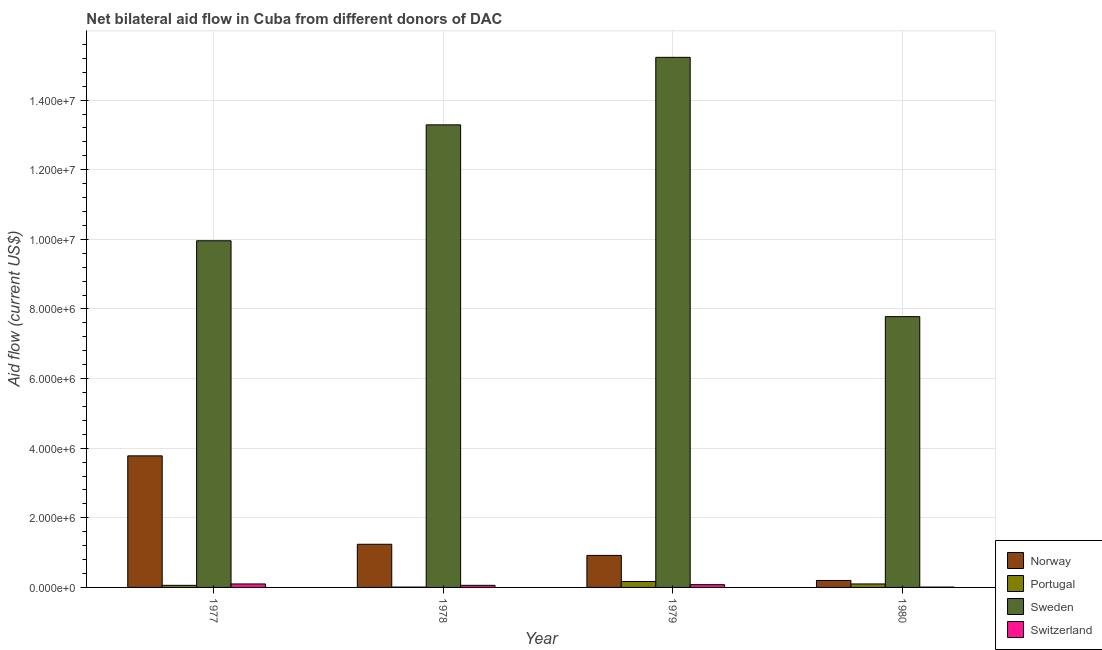How many different coloured bars are there?
Your answer should be very brief. 4. Are the number of bars per tick equal to the number of legend labels?
Your answer should be compact. Yes. Are the number of bars on each tick of the X-axis equal?
Provide a succinct answer. Yes. How many bars are there on the 2nd tick from the left?
Your response must be concise. 4. What is the label of the 3rd group of bars from the left?
Provide a short and direct response. 1979. In how many cases, is the number of bars for a given year not equal to the number of legend labels?
Ensure brevity in your answer.  0. What is the amount of aid given by portugal in 1977?
Make the answer very short. 6.00e+04. Across all years, what is the maximum amount of aid given by portugal?
Keep it short and to the point. 1.70e+05. Across all years, what is the minimum amount of aid given by norway?
Make the answer very short. 2.00e+05. In which year was the amount of aid given by switzerland maximum?
Give a very brief answer. 1977. In which year was the amount of aid given by portugal minimum?
Ensure brevity in your answer.  1978. What is the total amount of aid given by portugal in the graph?
Provide a succinct answer. 3.40e+05. What is the difference between the amount of aid given by norway in 1979 and that in 1980?
Make the answer very short. 7.20e+05. What is the difference between the amount of aid given by sweden in 1979 and the amount of aid given by norway in 1978?
Keep it short and to the point. 1.94e+06. What is the average amount of aid given by sweden per year?
Your answer should be compact. 1.16e+07. In the year 1979, what is the difference between the amount of aid given by portugal and amount of aid given by switzerland?
Keep it short and to the point. 0. In how many years, is the amount of aid given by sweden greater than 14400000 US$?
Your answer should be very brief. 1. Is the amount of aid given by switzerland in 1977 less than that in 1980?
Ensure brevity in your answer.  No. What is the difference between the highest and the second highest amount of aid given by sweden?
Provide a succinct answer. 1.94e+06. What is the difference between the highest and the lowest amount of aid given by portugal?
Make the answer very short. 1.60e+05. In how many years, is the amount of aid given by norway greater than the average amount of aid given by norway taken over all years?
Your response must be concise. 1. Is the sum of the amount of aid given by norway in 1977 and 1979 greater than the maximum amount of aid given by sweden across all years?
Provide a short and direct response. Yes. Is it the case that in every year, the sum of the amount of aid given by sweden and amount of aid given by switzerland is greater than the sum of amount of aid given by portugal and amount of aid given by norway?
Your answer should be compact. Yes. What does the 1st bar from the left in 1978 represents?
Keep it short and to the point. Norway. What does the 1st bar from the right in 1978 represents?
Your answer should be very brief. Switzerland. How many bars are there?
Offer a terse response. 16. Are all the bars in the graph horizontal?
Provide a succinct answer. No. How many years are there in the graph?
Give a very brief answer. 4. What is the difference between two consecutive major ticks on the Y-axis?
Offer a very short reply. 2.00e+06. Does the graph contain any zero values?
Keep it short and to the point. No. Does the graph contain grids?
Keep it short and to the point. Yes. How many legend labels are there?
Your answer should be very brief. 4. What is the title of the graph?
Offer a very short reply. Net bilateral aid flow in Cuba from different donors of DAC. What is the label or title of the X-axis?
Provide a succinct answer. Year. What is the Aid flow (current US$) in Norway in 1977?
Offer a terse response. 3.78e+06. What is the Aid flow (current US$) of Sweden in 1977?
Your response must be concise. 9.96e+06. What is the Aid flow (current US$) in Switzerland in 1977?
Your answer should be compact. 1.00e+05. What is the Aid flow (current US$) in Norway in 1978?
Ensure brevity in your answer.  1.24e+06. What is the Aid flow (current US$) of Portugal in 1978?
Offer a terse response. 10000. What is the Aid flow (current US$) of Sweden in 1978?
Your answer should be compact. 1.33e+07. What is the Aid flow (current US$) of Norway in 1979?
Keep it short and to the point. 9.20e+05. What is the Aid flow (current US$) of Sweden in 1979?
Provide a succinct answer. 1.52e+07. What is the Aid flow (current US$) in Portugal in 1980?
Keep it short and to the point. 1.00e+05. What is the Aid flow (current US$) in Sweden in 1980?
Make the answer very short. 7.78e+06. What is the Aid flow (current US$) in Switzerland in 1980?
Your response must be concise. 10000. Across all years, what is the maximum Aid flow (current US$) in Norway?
Provide a succinct answer. 3.78e+06. Across all years, what is the maximum Aid flow (current US$) in Portugal?
Your answer should be compact. 1.70e+05. Across all years, what is the maximum Aid flow (current US$) of Sweden?
Your answer should be very brief. 1.52e+07. Across all years, what is the minimum Aid flow (current US$) in Sweden?
Provide a short and direct response. 7.78e+06. What is the total Aid flow (current US$) in Norway in the graph?
Provide a succinct answer. 6.14e+06. What is the total Aid flow (current US$) in Portugal in the graph?
Your answer should be very brief. 3.40e+05. What is the total Aid flow (current US$) in Sweden in the graph?
Offer a very short reply. 4.63e+07. What is the difference between the Aid flow (current US$) in Norway in 1977 and that in 1978?
Make the answer very short. 2.54e+06. What is the difference between the Aid flow (current US$) of Portugal in 1977 and that in 1978?
Offer a terse response. 5.00e+04. What is the difference between the Aid flow (current US$) in Sweden in 1977 and that in 1978?
Your answer should be very brief. -3.33e+06. What is the difference between the Aid flow (current US$) in Switzerland in 1977 and that in 1978?
Provide a short and direct response. 4.00e+04. What is the difference between the Aid flow (current US$) of Norway in 1977 and that in 1979?
Your answer should be compact. 2.86e+06. What is the difference between the Aid flow (current US$) of Portugal in 1977 and that in 1979?
Your answer should be compact. -1.10e+05. What is the difference between the Aid flow (current US$) in Sweden in 1977 and that in 1979?
Keep it short and to the point. -5.27e+06. What is the difference between the Aid flow (current US$) in Norway in 1977 and that in 1980?
Make the answer very short. 3.58e+06. What is the difference between the Aid flow (current US$) in Portugal in 1977 and that in 1980?
Offer a very short reply. -4.00e+04. What is the difference between the Aid flow (current US$) of Sweden in 1977 and that in 1980?
Offer a terse response. 2.18e+06. What is the difference between the Aid flow (current US$) of Portugal in 1978 and that in 1979?
Provide a short and direct response. -1.60e+05. What is the difference between the Aid flow (current US$) of Sweden in 1978 and that in 1979?
Ensure brevity in your answer.  -1.94e+06. What is the difference between the Aid flow (current US$) of Switzerland in 1978 and that in 1979?
Offer a terse response. -2.00e+04. What is the difference between the Aid flow (current US$) in Norway in 1978 and that in 1980?
Provide a succinct answer. 1.04e+06. What is the difference between the Aid flow (current US$) in Portugal in 1978 and that in 1980?
Provide a short and direct response. -9.00e+04. What is the difference between the Aid flow (current US$) in Sweden in 1978 and that in 1980?
Keep it short and to the point. 5.51e+06. What is the difference between the Aid flow (current US$) of Switzerland in 1978 and that in 1980?
Your response must be concise. 5.00e+04. What is the difference between the Aid flow (current US$) of Norway in 1979 and that in 1980?
Your response must be concise. 7.20e+05. What is the difference between the Aid flow (current US$) of Sweden in 1979 and that in 1980?
Offer a very short reply. 7.45e+06. What is the difference between the Aid flow (current US$) in Norway in 1977 and the Aid flow (current US$) in Portugal in 1978?
Your answer should be very brief. 3.77e+06. What is the difference between the Aid flow (current US$) of Norway in 1977 and the Aid flow (current US$) of Sweden in 1978?
Your answer should be very brief. -9.51e+06. What is the difference between the Aid flow (current US$) in Norway in 1977 and the Aid flow (current US$) in Switzerland in 1978?
Make the answer very short. 3.72e+06. What is the difference between the Aid flow (current US$) in Portugal in 1977 and the Aid flow (current US$) in Sweden in 1978?
Keep it short and to the point. -1.32e+07. What is the difference between the Aid flow (current US$) of Sweden in 1977 and the Aid flow (current US$) of Switzerland in 1978?
Your answer should be compact. 9.90e+06. What is the difference between the Aid flow (current US$) in Norway in 1977 and the Aid flow (current US$) in Portugal in 1979?
Offer a very short reply. 3.61e+06. What is the difference between the Aid flow (current US$) of Norway in 1977 and the Aid flow (current US$) of Sweden in 1979?
Your answer should be very brief. -1.14e+07. What is the difference between the Aid flow (current US$) in Norway in 1977 and the Aid flow (current US$) in Switzerland in 1979?
Offer a terse response. 3.70e+06. What is the difference between the Aid flow (current US$) of Portugal in 1977 and the Aid flow (current US$) of Sweden in 1979?
Your answer should be compact. -1.52e+07. What is the difference between the Aid flow (current US$) in Portugal in 1977 and the Aid flow (current US$) in Switzerland in 1979?
Your answer should be compact. -2.00e+04. What is the difference between the Aid flow (current US$) in Sweden in 1977 and the Aid flow (current US$) in Switzerland in 1979?
Your answer should be compact. 9.88e+06. What is the difference between the Aid flow (current US$) in Norway in 1977 and the Aid flow (current US$) in Portugal in 1980?
Your answer should be compact. 3.68e+06. What is the difference between the Aid flow (current US$) of Norway in 1977 and the Aid flow (current US$) of Switzerland in 1980?
Your answer should be compact. 3.77e+06. What is the difference between the Aid flow (current US$) in Portugal in 1977 and the Aid flow (current US$) in Sweden in 1980?
Make the answer very short. -7.72e+06. What is the difference between the Aid flow (current US$) of Sweden in 1977 and the Aid flow (current US$) of Switzerland in 1980?
Provide a short and direct response. 9.95e+06. What is the difference between the Aid flow (current US$) of Norway in 1978 and the Aid flow (current US$) of Portugal in 1979?
Offer a terse response. 1.07e+06. What is the difference between the Aid flow (current US$) in Norway in 1978 and the Aid flow (current US$) in Sweden in 1979?
Provide a succinct answer. -1.40e+07. What is the difference between the Aid flow (current US$) in Norway in 1978 and the Aid flow (current US$) in Switzerland in 1979?
Make the answer very short. 1.16e+06. What is the difference between the Aid flow (current US$) of Portugal in 1978 and the Aid flow (current US$) of Sweden in 1979?
Offer a very short reply. -1.52e+07. What is the difference between the Aid flow (current US$) in Sweden in 1978 and the Aid flow (current US$) in Switzerland in 1979?
Your response must be concise. 1.32e+07. What is the difference between the Aid flow (current US$) of Norway in 1978 and the Aid flow (current US$) of Portugal in 1980?
Give a very brief answer. 1.14e+06. What is the difference between the Aid flow (current US$) in Norway in 1978 and the Aid flow (current US$) in Sweden in 1980?
Offer a terse response. -6.54e+06. What is the difference between the Aid flow (current US$) of Norway in 1978 and the Aid flow (current US$) of Switzerland in 1980?
Provide a short and direct response. 1.23e+06. What is the difference between the Aid flow (current US$) of Portugal in 1978 and the Aid flow (current US$) of Sweden in 1980?
Offer a terse response. -7.77e+06. What is the difference between the Aid flow (current US$) of Portugal in 1978 and the Aid flow (current US$) of Switzerland in 1980?
Provide a succinct answer. 0. What is the difference between the Aid flow (current US$) in Sweden in 1978 and the Aid flow (current US$) in Switzerland in 1980?
Your answer should be compact. 1.33e+07. What is the difference between the Aid flow (current US$) of Norway in 1979 and the Aid flow (current US$) of Portugal in 1980?
Give a very brief answer. 8.20e+05. What is the difference between the Aid flow (current US$) in Norway in 1979 and the Aid flow (current US$) in Sweden in 1980?
Provide a short and direct response. -6.86e+06. What is the difference between the Aid flow (current US$) in Norway in 1979 and the Aid flow (current US$) in Switzerland in 1980?
Give a very brief answer. 9.10e+05. What is the difference between the Aid flow (current US$) in Portugal in 1979 and the Aid flow (current US$) in Sweden in 1980?
Keep it short and to the point. -7.61e+06. What is the difference between the Aid flow (current US$) in Sweden in 1979 and the Aid flow (current US$) in Switzerland in 1980?
Provide a short and direct response. 1.52e+07. What is the average Aid flow (current US$) in Norway per year?
Your answer should be very brief. 1.54e+06. What is the average Aid flow (current US$) in Portugal per year?
Ensure brevity in your answer.  8.50e+04. What is the average Aid flow (current US$) in Sweden per year?
Your answer should be compact. 1.16e+07. What is the average Aid flow (current US$) of Switzerland per year?
Your answer should be compact. 6.25e+04. In the year 1977, what is the difference between the Aid flow (current US$) in Norway and Aid flow (current US$) in Portugal?
Provide a succinct answer. 3.72e+06. In the year 1977, what is the difference between the Aid flow (current US$) in Norway and Aid flow (current US$) in Sweden?
Offer a terse response. -6.18e+06. In the year 1977, what is the difference between the Aid flow (current US$) in Norway and Aid flow (current US$) in Switzerland?
Your answer should be very brief. 3.68e+06. In the year 1977, what is the difference between the Aid flow (current US$) of Portugal and Aid flow (current US$) of Sweden?
Provide a short and direct response. -9.90e+06. In the year 1977, what is the difference between the Aid flow (current US$) of Portugal and Aid flow (current US$) of Switzerland?
Provide a short and direct response. -4.00e+04. In the year 1977, what is the difference between the Aid flow (current US$) in Sweden and Aid flow (current US$) in Switzerland?
Give a very brief answer. 9.86e+06. In the year 1978, what is the difference between the Aid flow (current US$) in Norway and Aid flow (current US$) in Portugal?
Your answer should be very brief. 1.23e+06. In the year 1978, what is the difference between the Aid flow (current US$) of Norway and Aid flow (current US$) of Sweden?
Ensure brevity in your answer.  -1.20e+07. In the year 1978, what is the difference between the Aid flow (current US$) in Norway and Aid flow (current US$) in Switzerland?
Offer a terse response. 1.18e+06. In the year 1978, what is the difference between the Aid flow (current US$) of Portugal and Aid flow (current US$) of Sweden?
Provide a short and direct response. -1.33e+07. In the year 1978, what is the difference between the Aid flow (current US$) of Portugal and Aid flow (current US$) of Switzerland?
Make the answer very short. -5.00e+04. In the year 1978, what is the difference between the Aid flow (current US$) in Sweden and Aid flow (current US$) in Switzerland?
Give a very brief answer. 1.32e+07. In the year 1979, what is the difference between the Aid flow (current US$) in Norway and Aid flow (current US$) in Portugal?
Provide a succinct answer. 7.50e+05. In the year 1979, what is the difference between the Aid flow (current US$) of Norway and Aid flow (current US$) of Sweden?
Your answer should be compact. -1.43e+07. In the year 1979, what is the difference between the Aid flow (current US$) of Norway and Aid flow (current US$) of Switzerland?
Provide a succinct answer. 8.40e+05. In the year 1979, what is the difference between the Aid flow (current US$) in Portugal and Aid flow (current US$) in Sweden?
Your answer should be compact. -1.51e+07. In the year 1979, what is the difference between the Aid flow (current US$) of Portugal and Aid flow (current US$) of Switzerland?
Provide a short and direct response. 9.00e+04. In the year 1979, what is the difference between the Aid flow (current US$) of Sweden and Aid flow (current US$) of Switzerland?
Keep it short and to the point. 1.52e+07. In the year 1980, what is the difference between the Aid flow (current US$) in Norway and Aid flow (current US$) in Sweden?
Keep it short and to the point. -7.58e+06. In the year 1980, what is the difference between the Aid flow (current US$) of Norway and Aid flow (current US$) of Switzerland?
Provide a short and direct response. 1.90e+05. In the year 1980, what is the difference between the Aid flow (current US$) of Portugal and Aid flow (current US$) of Sweden?
Keep it short and to the point. -7.68e+06. In the year 1980, what is the difference between the Aid flow (current US$) in Sweden and Aid flow (current US$) in Switzerland?
Provide a short and direct response. 7.77e+06. What is the ratio of the Aid flow (current US$) of Norway in 1977 to that in 1978?
Offer a very short reply. 3.05. What is the ratio of the Aid flow (current US$) of Sweden in 1977 to that in 1978?
Your answer should be very brief. 0.75. What is the ratio of the Aid flow (current US$) of Switzerland in 1977 to that in 1978?
Provide a succinct answer. 1.67. What is the ratio of the Aid flow (current US$) of Norway in 1977 to that in 1979?
Provide a short and direct response. 4.11. What is the ratio of the Aid flow (current US$) in Portugal in 1977 to that in 1979?
Your answer should be compact. 0.35. What is the ratio of the Aid flow (current US$) of Sweden in 1977 to that in 1979?
Your answer should be very brief. 0.65. What is the ratio of the Aid flow (current US$) in Switzerland in 1977 to that in 1979?
Your answer should be compact. 1.25. What is the ratio of the Aid flow (current US$) of Portugal in 1977 to that in 1980?
Offer a very short reply. 0.6. What is the ratio of the Aid flow (current US$) in Sweden in 1977 to that in 1980?
Keep it short and to the point. 1.28. What is the ratio of the Aid flow (current US$) in Switzerland in 1977 to that in 1980?
Make the answer very short. 10. What is the ratio of the Aid flow (current US$) in Norway in 1978 to that in 1979?
Ensure brevity in your answer.  1.35. What is the ratio of the Aid flow (current US$) in Portugal in 1978 to that in 1979?
Provide a succinct answer. 0.06. What is the ratio of the Aid flow (current US$) in Sweden in 1978 to that in 1979?
Ensure brevity in your answer.  0.87. What is the ratio of the Aid flow (current US$) in Norway in 1978 to that in 1980?
Offer a very short reply. 6.2. What is the ratio of the Aid flow (current US$) of Sweden in 1978 to that in 1980?
Offer a terse response. 1.71. What is the ratio of the Aid flow (current US$) in Sweden in 1979 to that in 1980?
Ensure brevity in your answer.  1.96. What is the ratio of the Aid flow (current US$) in Switzerland in 1979 to that in 1980?
Offer a terse response. 8. What is the difference between the highest and the second highest Aid flow (current US$) in Norway?
Your response must be concise. 2.54e+06. What is the difference between the highest and the second highest Aid flow (current US$) in Portugal?
Provide a short and direct response. 7.00e+04. What is the difference between the highest and the second highest Aid flow (current US$) in Sweden?
Ensure brevity in your answer.  1.94e+06. What is the difference between the highest and the second highest Aid flow (current US$) of Switzerland?
Provide a succinct answer. 2.00e+04. What is the difference between the highest and the lowest Aid flow (current US$) of Norway?
Keep it short and to the point. 3.58e+06. What is the difference between the highest and the lowest Aid flow (current US$) in Portugal?
Offer a very short reply. 1.60e+05. What is the difference between the highest and the lowest Aid flow (current US$) of Sweden?
Your response must be concise. 7.45e+06. 